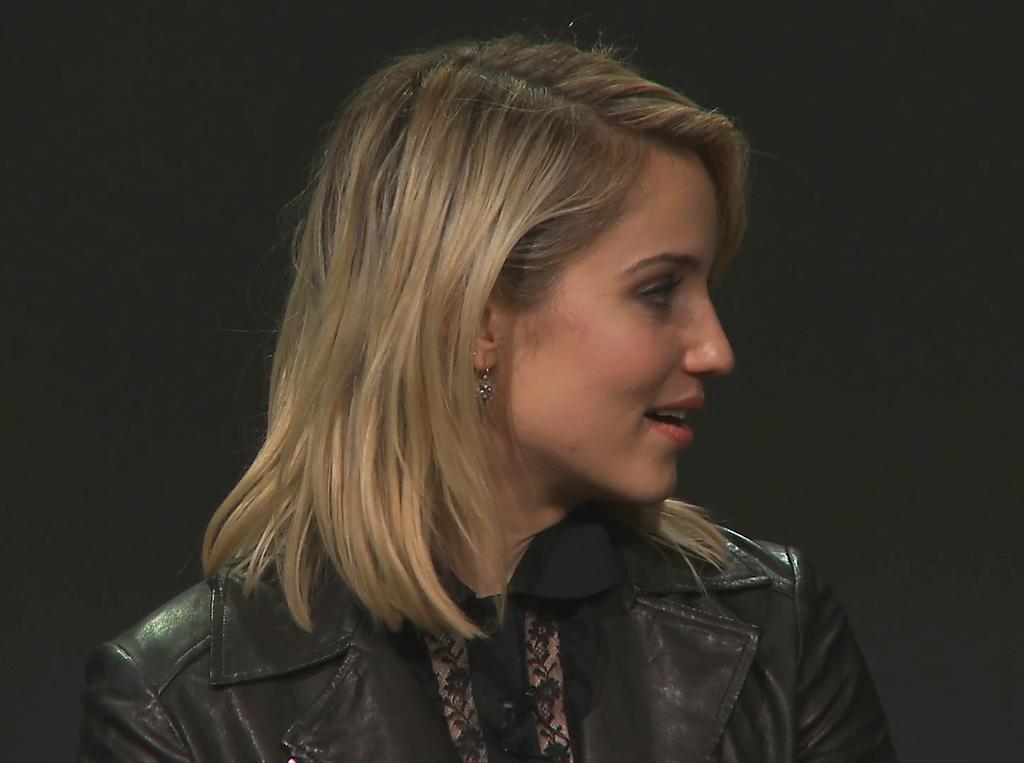In one or two sentences, can you explain what this image depicts? In this image I can see the person and the person is wearing black color jacket and I can see the dark background. 